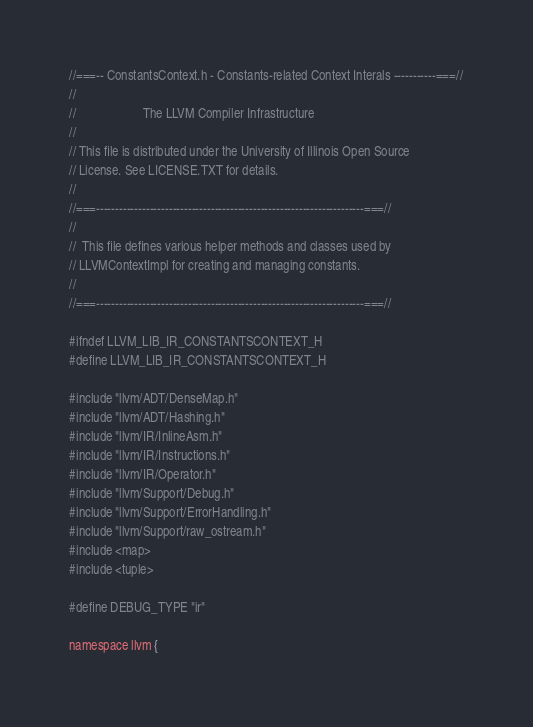<code> <loc_0><loc_0><loc_500><loc_500><_C_>//===-- ConstantsContext.h - Constants-related Context Interals -----------===//
//
//                     The LLVM Compiler Infrastructure
//
// This file is distributed under the University of Illinois Open Source
// License. See LICENSE.TXT for details.
//
//===----------------------------------------------------------------------===//
//
//  This file defines various helper methods and classes used by
// LLVMContextImpl for creating and managing constants.
//
//===----------------------------------------------------------------------===//

#ifndef LLVM_LIB_IR_CONSTANTSCONTEXT_H
#define LLVM_LIB_IR_CONSTANTSCONTEXT_H

#include "llvm/ADT/DenseMap.h"
#include "llvm/ADT/Hashing.h"
#include "llvm/IR/InlineAsm.h"
#include "llvm/IR/Instructions.h"
#include "llvm/IR/Operator.h"
#include "llvm/Support/Debug.h"
#include "llvm/Support/ErrorHandling.h"
#include "llvm/Support/raw_ostream.h"
#include <map>
#include <tuple>

#define DEBUG_TYPE "ir"

namespace llvm {
</code> 